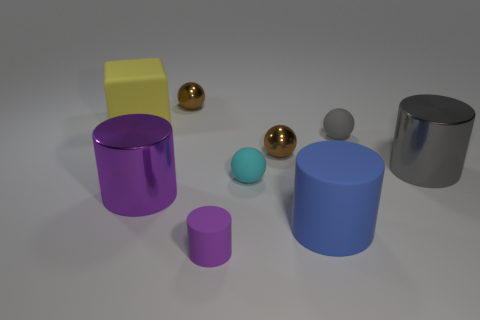Is there a metal cylinder that has the same color as the tiny matte cylinder?
Provide a succinct answer. Yes. Are there more things behind the gray metallic cylinder than tiny things behind the big blue matte cylinder?
Provide a short and direct response. No. Do the cyan object and the brown metallic object that is left of the small purple cylinder have the same shape?
Make the answer very short. Yes. What number of other objects are the same shape as the cyan thing?
Your response must be concise. 3. The small matte thing that is both on the left side of the blue cylinder and behind the small purple rubber object is what color?
Keep it short and to the point. Cyan. The big block has what color?
Provide a short and direct response. Yellow. Is the tiny purple cylinder made of the same material as the big cylinder behind the purple metallic cylinder?
Your answer should be compact. No. There is a small gray thing that is made of the same material as the tiny purple cylinder; what shape is it?
Provide a succinct answer. Sphere. What is the color of the rubber cylinder that is the same size as the gray sphere?
Provide a short and direct response. Purple. There is a brown thing in front of the matte cube; does it have the same size as the tiny purple cylinder?
Offer a terse response. Yes. 